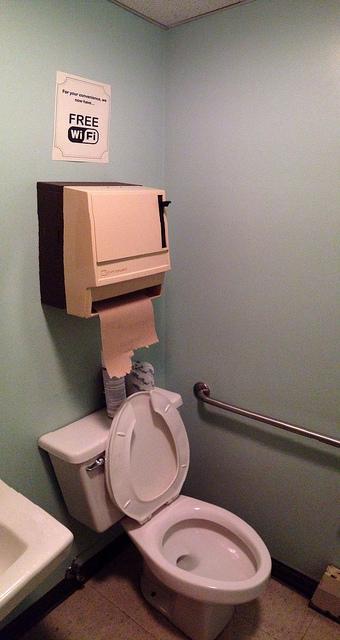Is the toilet seat up?
Answer briefly. Yes. What color are the signs?
Keep it brief. White. Is there a roll of toilet paper?
Be succinct. No. What word do you see clearly on the sign over the toilet?
Keep it brief. Free. 